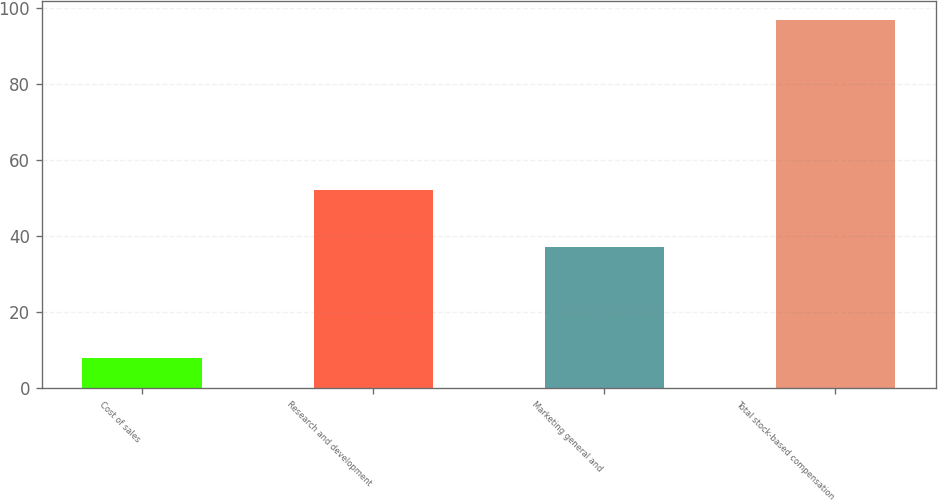<chart> <loc_0><loc_0><loc_500><loc_500><bar_chart><fcel>Cost of sales<fcel>Research and development<fcel>Marketing general and<fcel>Total stock-based compensation<nl><fcel>8<fcel>52<fcel>37<fcel>97<nl></chart> 